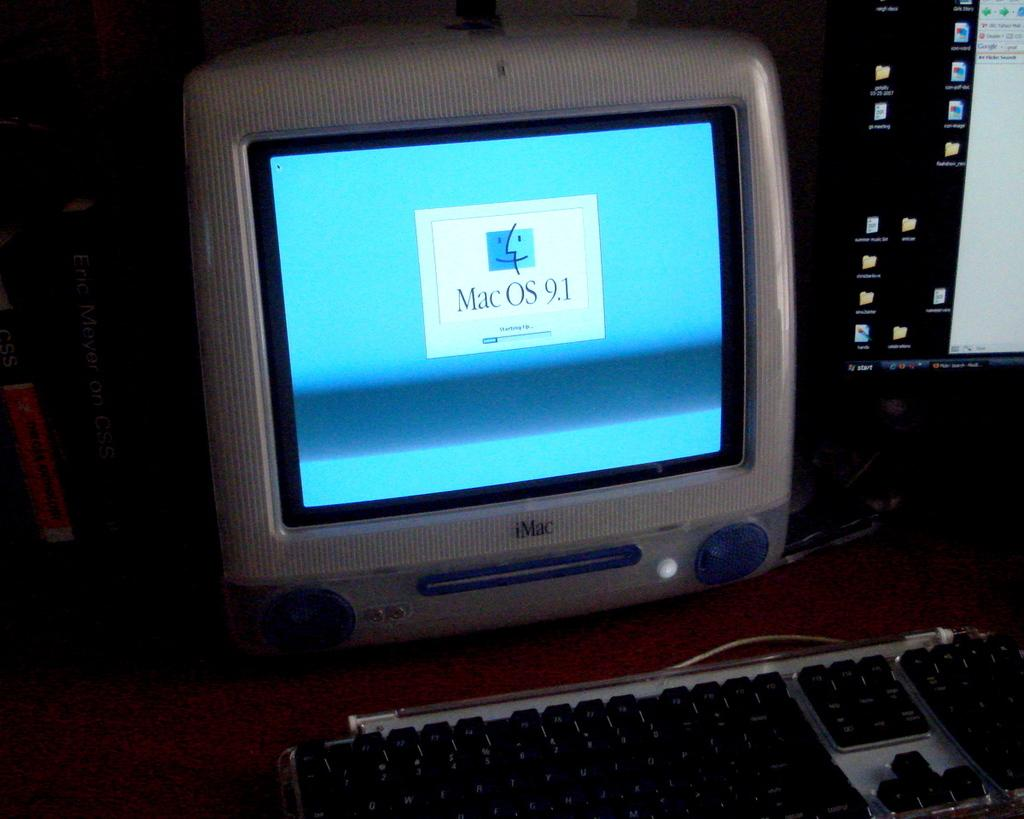<image>
Present a compact description of the photo's key features. Mac os 9.1 computer with keyboard and another computer beside it 